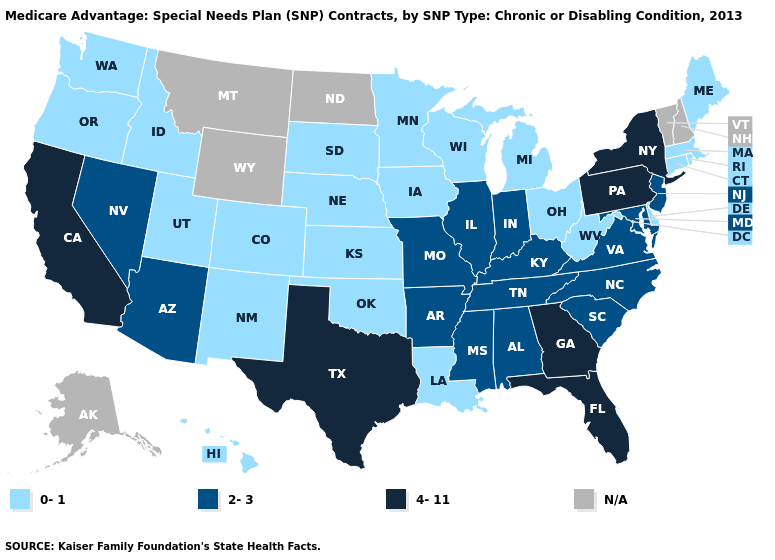Name the states that have a value in the range N/A?
Short answer required. Alaska, Montana, North Dakota, New Hampshire, Vermont, Wyoming. Does the map have missing data?
Quick response, please. Yes. Is the legend a continuous bar?
Be succinct. No. What is the value of Mississippi?
Concise answer only. 2-3. Name the states that have a value in the range N/A?
Concise answer only. Alaska, Montana, North Dakota, New Hampshire, Vermont, Wyoming. What is the value of Maine?
Keep it brief. 0-1. What is the value of Oregon?
Be succinct. 0-1. What is the value of Iowa?
Keep it brief. 0-1. Does Missouri have the highest value in the MidWest?
Quick response, please. Yes. Which states have the highest value in the USA?
Answer briefly. California, Florida, Georgia, New York, Pennsylvania, Texas. Among the states that border California , which have the lowest value?
Give a very brief answer. Oregon. Name the states that have a value in the range 4-11?
Give a very brief answer. California, Florida, Georgia, New York, Pennsylvania, Texas. Which states have the highest value in the USA?
Give a very brief answer. California, Florida, Georgia, New York, Pennsylvania, Texas. Does the map have missing data?
Concise answer only. Yes. 